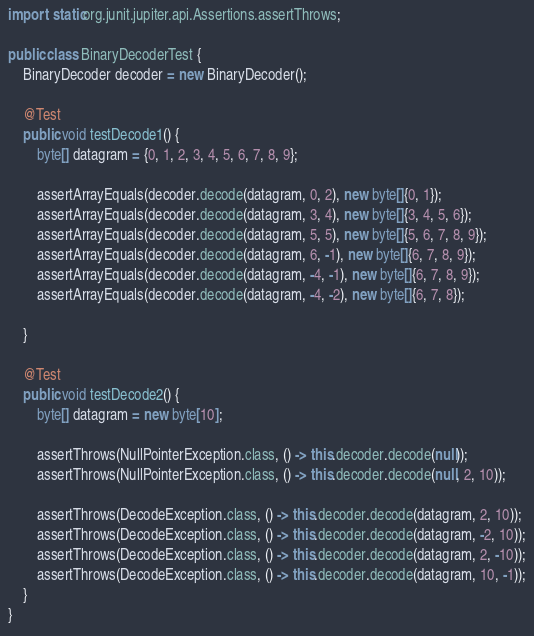<code> <loc_0><loc_0><loc_500><loc_500><_Java_>import static org.junit.jupiter.api.Assertions.assertThrows;

public class BinaryDecoderTest {
    BinaryDecoder decoder = new BinaryDecoder();

    @Test
    public void testDecode1() {
        byte[] datagram = {0, 1, 2, 3, 4, 5, 6, 7, 8, 9};

        assertArrayEquals(decoder.decode(datagram, 0, 2), new byte[]{0, 1});
        assertArrayEquals(decoder.decode(datagram, 3, 4), new byte[]{3, 4, 5, 6});
        assertArrayEquals(decoder.decode(datagram, 5, 5), new byte[]{5, 6, 7, 8, 9});
        assertArrayEquals(decoder.decode(datagram, 6, -1), new byte[]{6, 7, 8, 9});
        assertArrayEquals(decoder.decode(datagram, -4, -1), new byte[]{6, 7, 8, 9});
        assertArrayEquals(decoder.decode(datagram, -4, -2), new byte[]{6, 7, 8});

    }

    @Test
    public void testDecode2() {
        byte[] datagram = new byte[10];

        assertThrows(NullPointerException.class, () -> this.decoder.decode(null));
        assertThrows(NullPointerException.class, () -> this.decoder.decode(null, 2, 10));

        assertThrows(DecodeException.class, () -> this.decoder.decode(datagram, 2, 10));
        assertThrows(DecodeException.class, () -> this.decoder.decode(datagram, -2, 10));
        assertThrows(DecodeException.class, () -> this.decoder.decode(datagram, 2, -10));
        assertThrows(DecodeException.class, () -> this.decoder.decode(datagram, 10, -1));
    }
}
</code> 